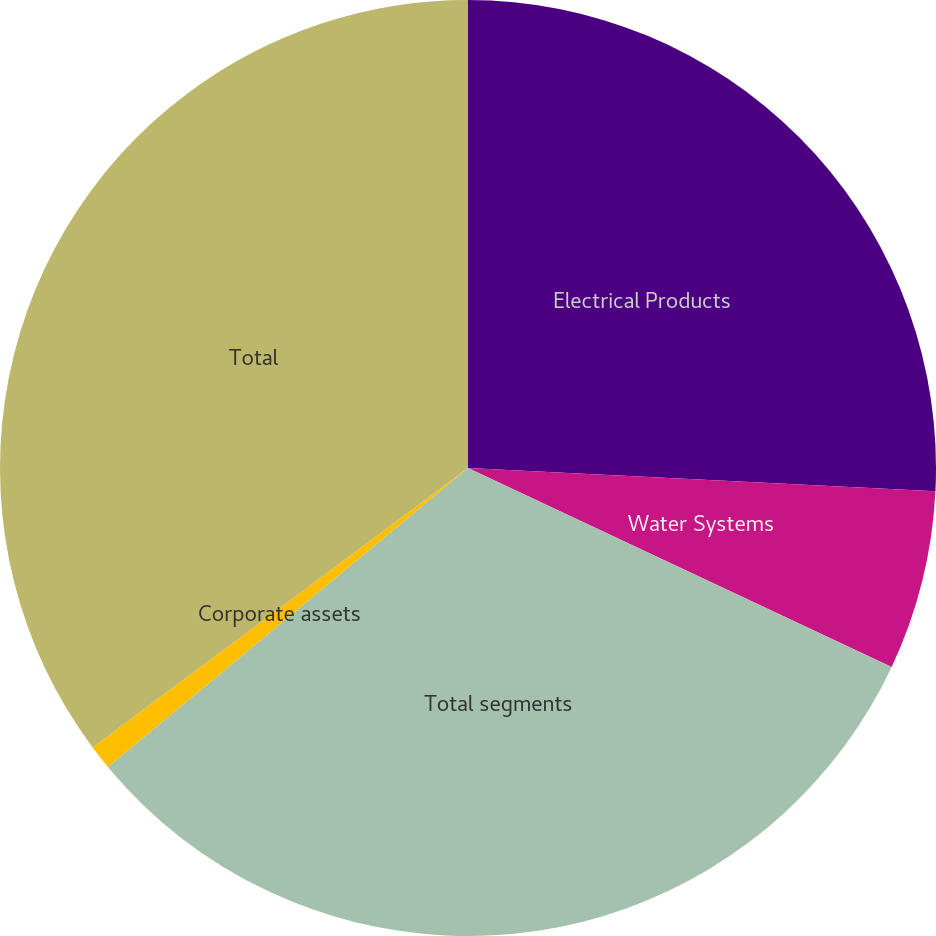Convert chart to OTSL. <chart><loc_0><loc_0><loc_500><loc_500><pie_chart><fcel>Electrical Products<fcel>Water Systems<fcel>Total segments<fcel>Corporate assets<fcel>Total<nl><fcel>25.79%<fcel>6.2%<fcel>31.99%<fcel>0.84%<fcel>35.19%<nl></chart> 